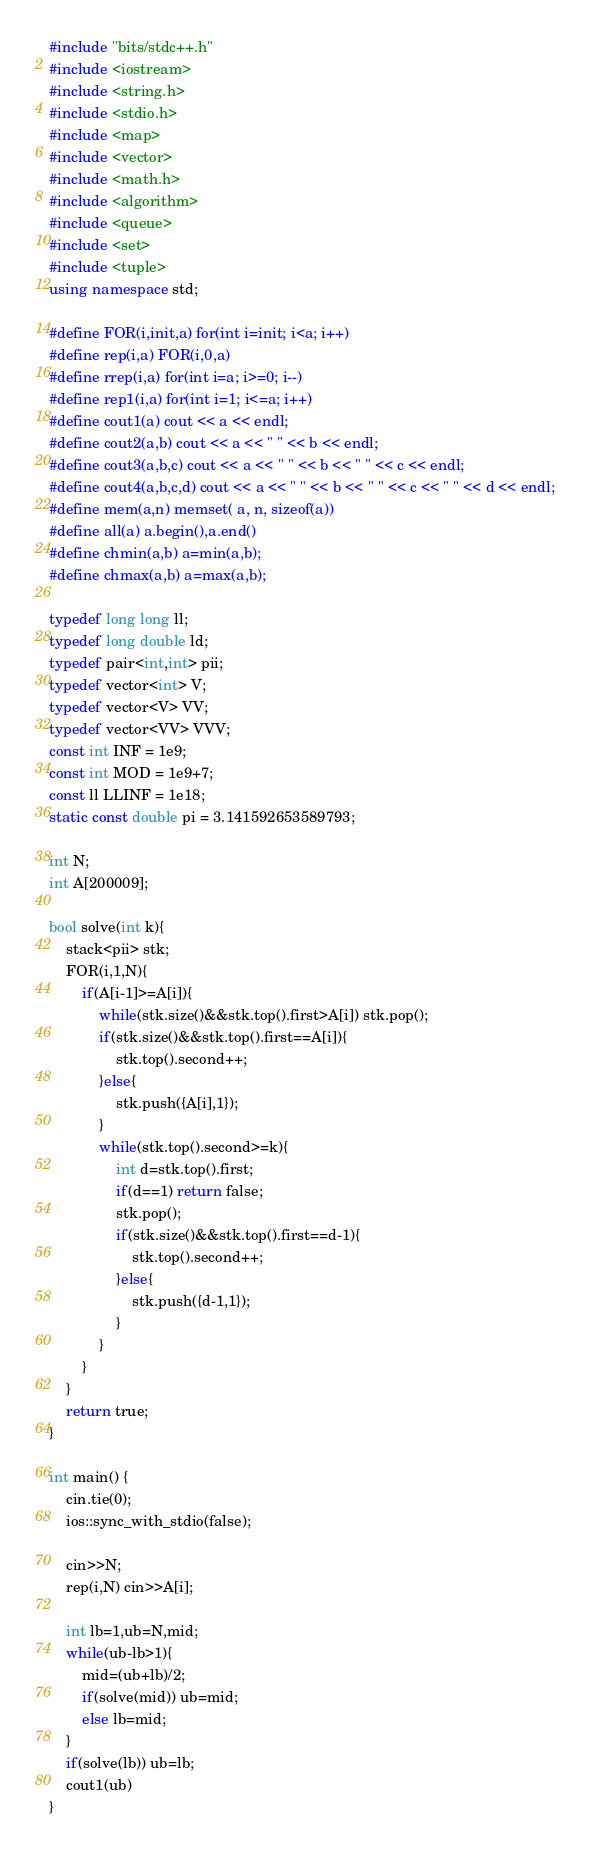Convert code to text. <code><loc_0><loc_0><loc_500><loc_500><_C++_>#include "bits/stdc++.h"
#include <iostream>
#include <string.h>
#include <stdio.h>
#include <map>
#include <vector>
#include <math.h>
#include <algorithm>
#include <queue>
#include <set>
#include <tuple>
using namespace std;

#define FOR(i,init,a) for(int i=init; i<a; i++)
#define rep(i,a) FOR(i,0,a)
#define rrep(i,a) for(int i=a; i>=0; i--)
#define rep1(i,a) for(int i=1; i<=a; i++)
#define cout1(a) cout << a << endl;
#define cout2(a,b) cout << a << " " << b << endl;
#define cout3(a,b,c) cout << a << " " << b << " " << c << endl;
#define cout4(a,b,c,d) cout << a << " " << b << " " << c << " " << d << endl;
#define mem(a,n) memset( a, n, sizeof(a))
#define all(a) a.begin(),a.end()
#define chmin(a,b) a=min(a,b);
#define chmax(a,b) a=max(a,b);

typedef long long ll;
typedef long double ld;
typedef pair<int,int> pii;
typedef vector<int> V;
typedef vector<V> VV;
typedef vector<VV> VVV;
const int INF = 1e9;
const int MOD = 1e9+7;
const ll LLINF = 1e18;
static const double pi = 3.141592653589793;

int N;
int A[200009];

bool solve(int k){
    stack<pii> stk;
    FOR(i,1,N){
        if(A[i-1]>=A[i]){
            while(stk.size()&&stk.top().first>A[i]) stk.pop();
            if(stk.size()&&stk.top().first==A[i]){
                stk.top().second++;
            }else{
                stk.push({A[i],1});
            }
            while(stk.top().second>=k){
                int d=stk.top().first;
                if(d==1) return false;
                stk.pop();
                if(stk.size()&&stk.top().first==d-1){
                    stk.top().second++;
                }else{
                    stk.push({d-1,1});
                }
            }
        }
    }
    return true;
}

int main() {
    cin.tie(0);
    ios::sync_with_stdio(false);
    
    cin>>N;
    rep(i,N) cin>>A[i];
    
    int lb=1,ub=N,mid;
    while(ub-lb>1){
        mid=(ub+lb)/2;
        if(solve(mid)) ub=mid;
        else lb=mid;
    }
    if(solve(lb)) ub=lb;
    cout1(ub)
}</code> 